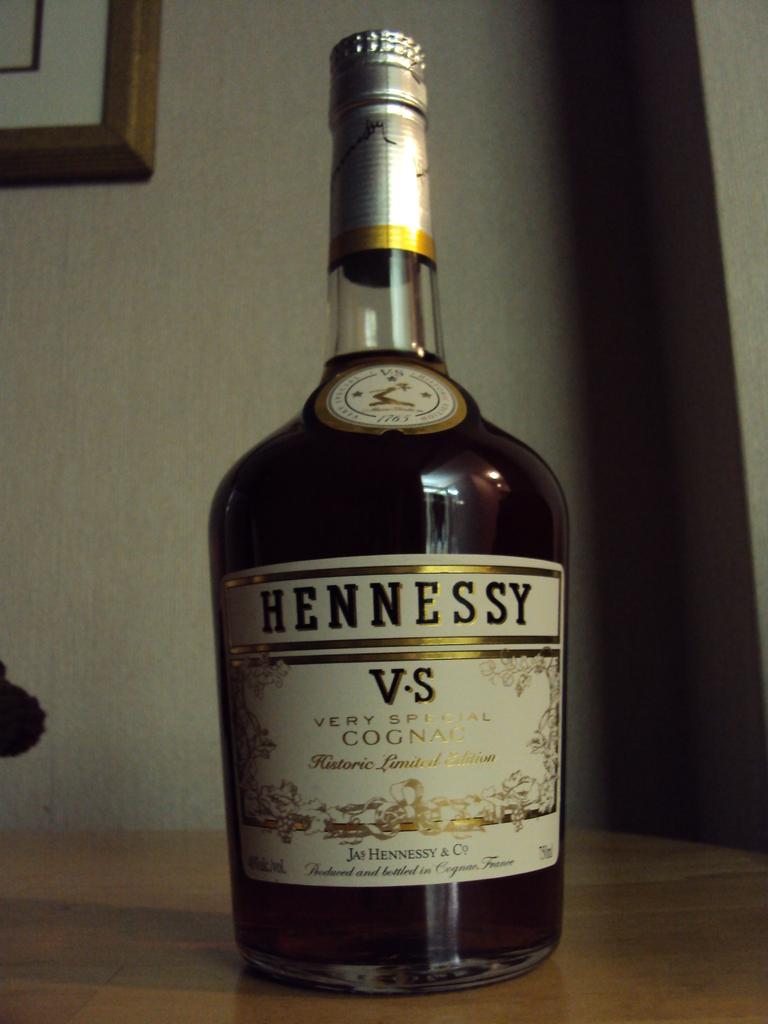What brand of alcohol is this?
Your response must be concise. Hennessy. 